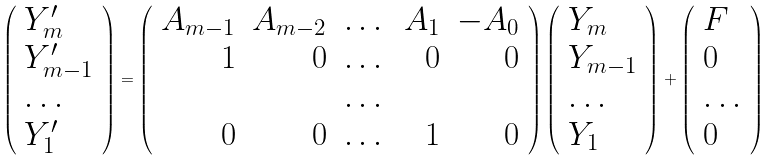Convert formula to latex. <formula><loc_0><loc_0><loc_500><loc_500>\left ( \begin{array} { l } Y _ { m } ^ { \prime } \\ Y _ { m - 1 } ^ { \prime } \\ \dots \\ Y _ { 1 } ^ { \prime } \end{array} \right ) = \left ( \begin{array} { r r r r r } A _ { m - 1 } & A _ { m - 2 } & \dots & A _ { 1 } & - A _ { 0 } \\ 1 & 0 & \dots & 0 & 0 \\ & & \dots & & \\ 0 & 0 & \dots & 1 & 0 \end{array} \right ) \left ( \begin{array} { l } Y _ { m } \\ Y _ { m - 1 } \\ \dots \\ Y _ { 1 } \end{array} \right ) + \left ( \begin{array} { l } F \\ 0 \\ \dots \\ 0 \end{array} \right )</formula> 